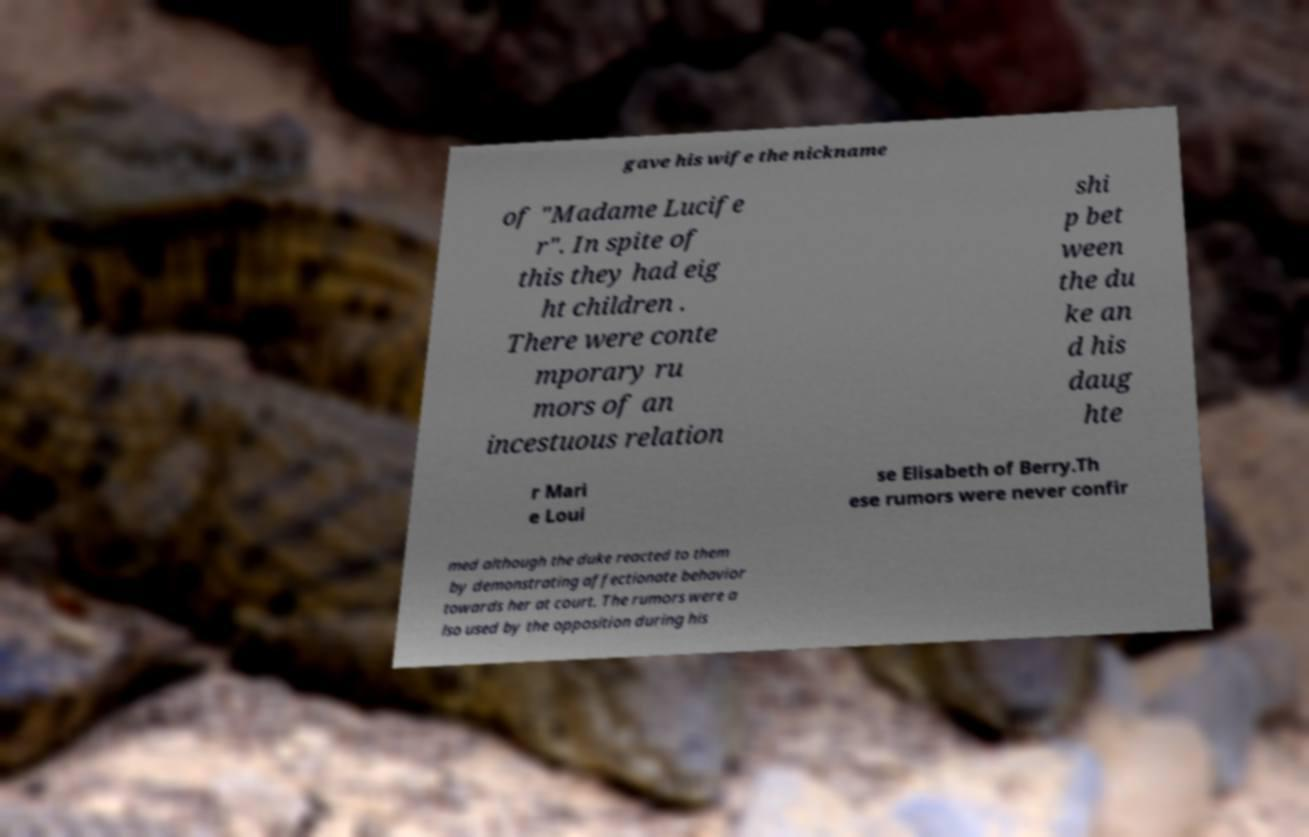Please identify and transcribe the text found in this image. gave his wife the nickname of "Madame Lucife r". In spite of this they had eig ht children . There were conte mporary ru mors of an incestuous relation shi p bet ween the du ke an d his daug hte r Mari e Loui se Elisabeth of Berry.Th ese rumors were never confir med although the duke reacted to them by demonstrating affectionate behavior towards her at court. The rumors were a lso used by the opposition during his 